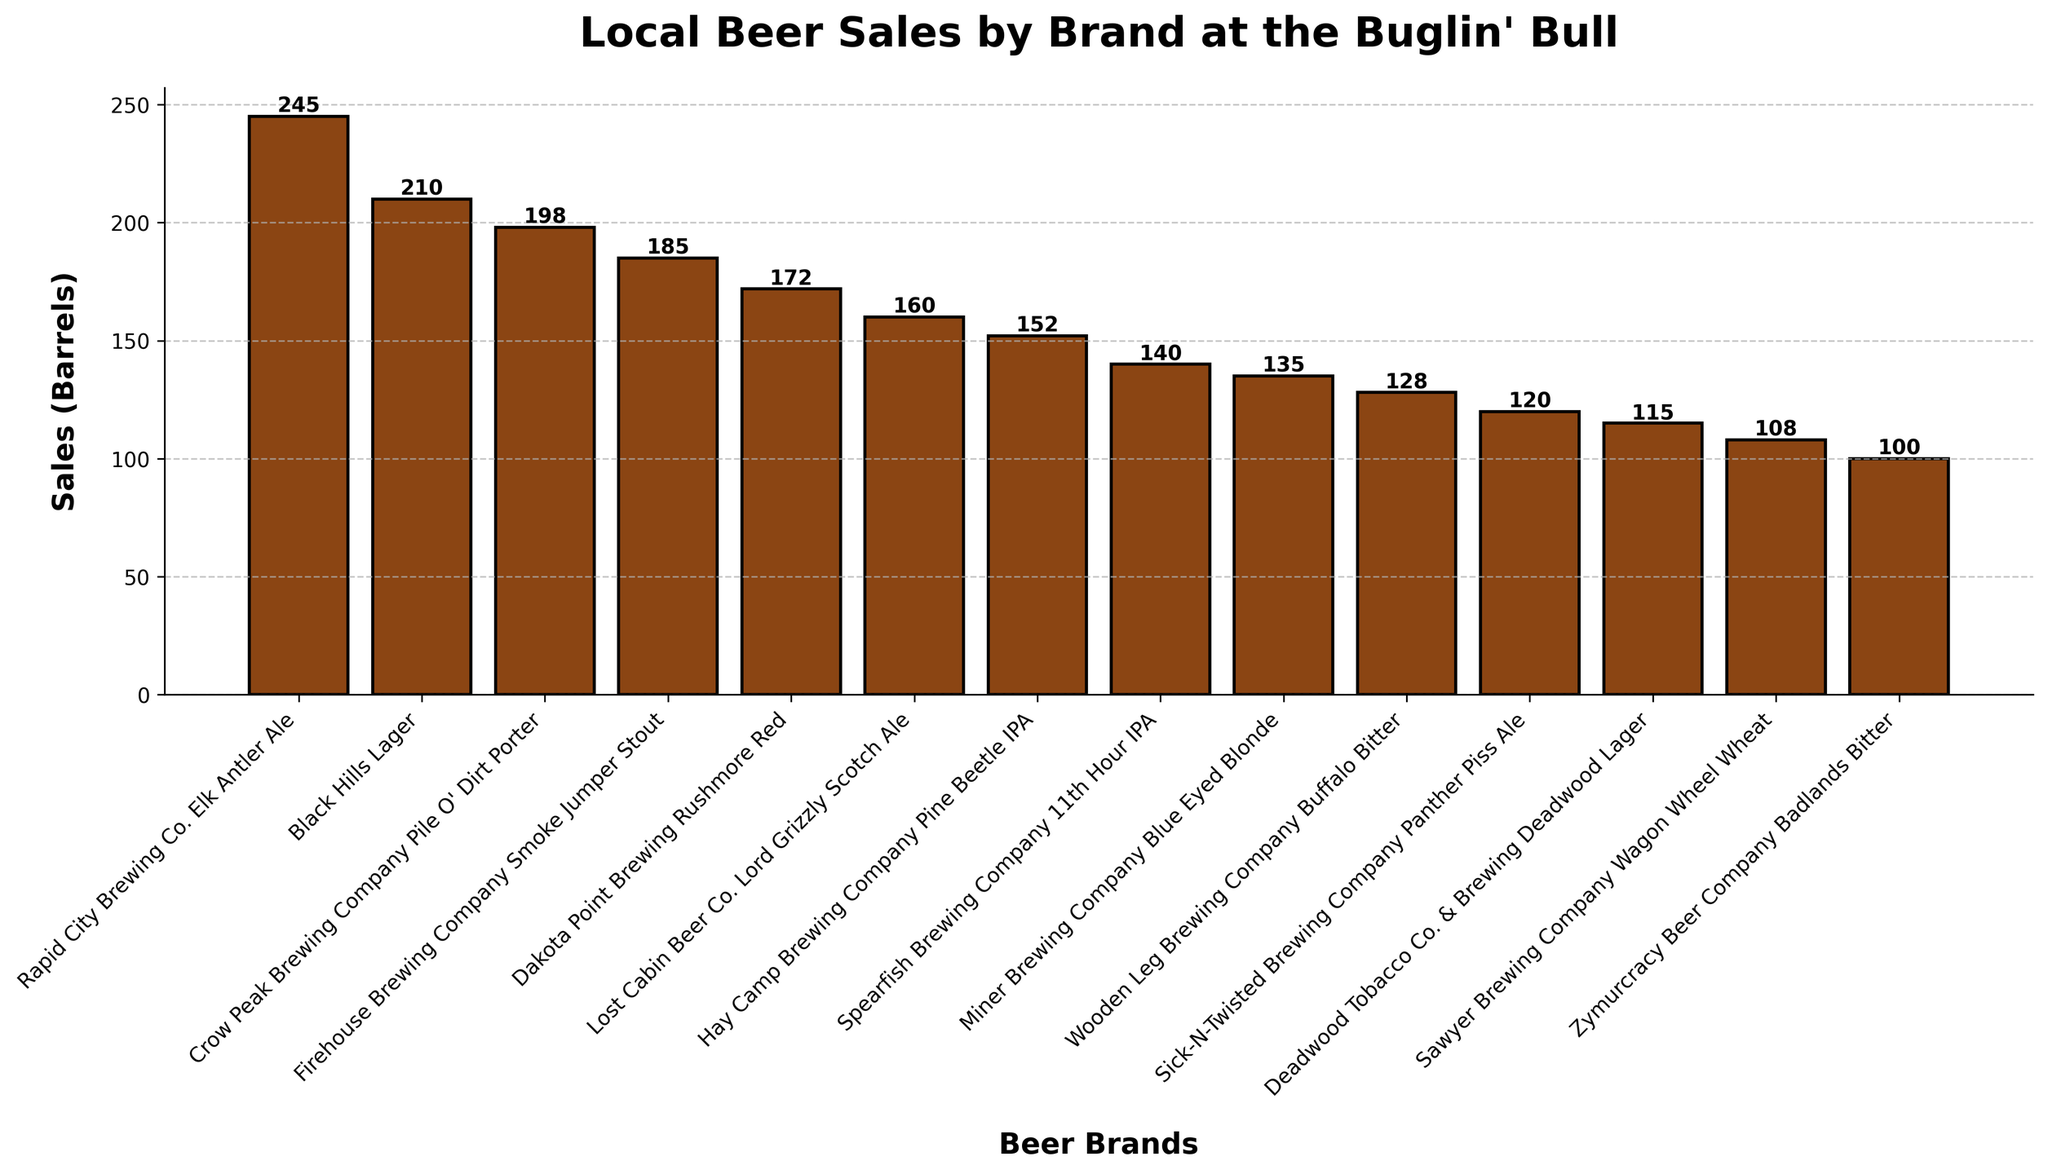Which brand has the highest sales at the Buglin' Bull? The tallest bar represents the brand with the highest sales, which is Rapid City Brewing Co. Elk Antler Ale with 245 barrels sold.
Answer: Rapid City Brewing Co. Elk Antler Ale Which two brands have the closest sales figures? The bars for Sawyer Brewing Company Wagon Wheel Wheat and Zymurcracy Beer Company Badlands Bitter are closest to each other in height, with sales of 108 and 100 barrels respectively.
Answer: Sawyer Brewing Company Wagon Wheel Wheat and Zymurcracy Beer Company Badlands Bitter What's the total number of barrels sold by Firehouse Brewing Company Smoke Jumper Stout, Dakota Point Brewing Rushmore Red, and Lost Cabin Beer Co. Lord Grizzly Scotch Ale combined? Add the sales figures for these three brands: 185 (Firehouse Brewing Company Smoke Jumper Stout) + 172 (Dakota Point Brewing Rushmore Red) + 160 (Lost Cabin Beer Co. Lord Grizzly Scotch Ale) = 517 barrels.
Answer: 517 barrels Which brand has lower sales: Crow Peak Brewing Company Pile O' Dirt Porter or Black Hills Lager? Compare the heights of the bars for these two brands. Crow Peak Brewing Company Pile O' Dirt Porter sold 198 barrels, while Black Hills Lager sold 210 barrels. Therefore, Crow Peak Brewing Company Pile O' Dirt Porter has lower sales.
Answer: Crow Peak Brewing Company Pile O' Dirt Porter What's the difference in sales between the highest and the lowest selling brands? Subtract the sales of the lowest selling brand (Zymurcracy Beer Company Badlands Bitter, 100 barrels) from the highest selling brand (Rapid City Brewing Co. Elk Antler Ale, 245 barrels): 245 - 100 = 145 barrels.
Answer: 145 barrels What’s the average sales of all beer brands at the Buglin' Bull? Add up all the sales and divide by the number of brands. Total sales: 245 + 210 + 198 + 185 + 172 + 160 + 152 + 140 + 135 + 128 + 120 + 115 + 108 + 100 = 2168 barrels. Number of brands: 14. Average sales: 2168 / 14 = 154.86 barrels.
Answer: 154.86 barrels Which brand just surpasses 150 barrels sales and is closest to the brand with 160 barrels sales? Hay Camp Brewing Company Pine Beetle IPA is just over 150 barrels with 152 barrels, and it is closest to Lost Cabin Beer Co. Lord Grizzly Scotch Ale which has 160 barrels sales.
Answer: Hay Camp Brewing Company Pine Beetle IPA 